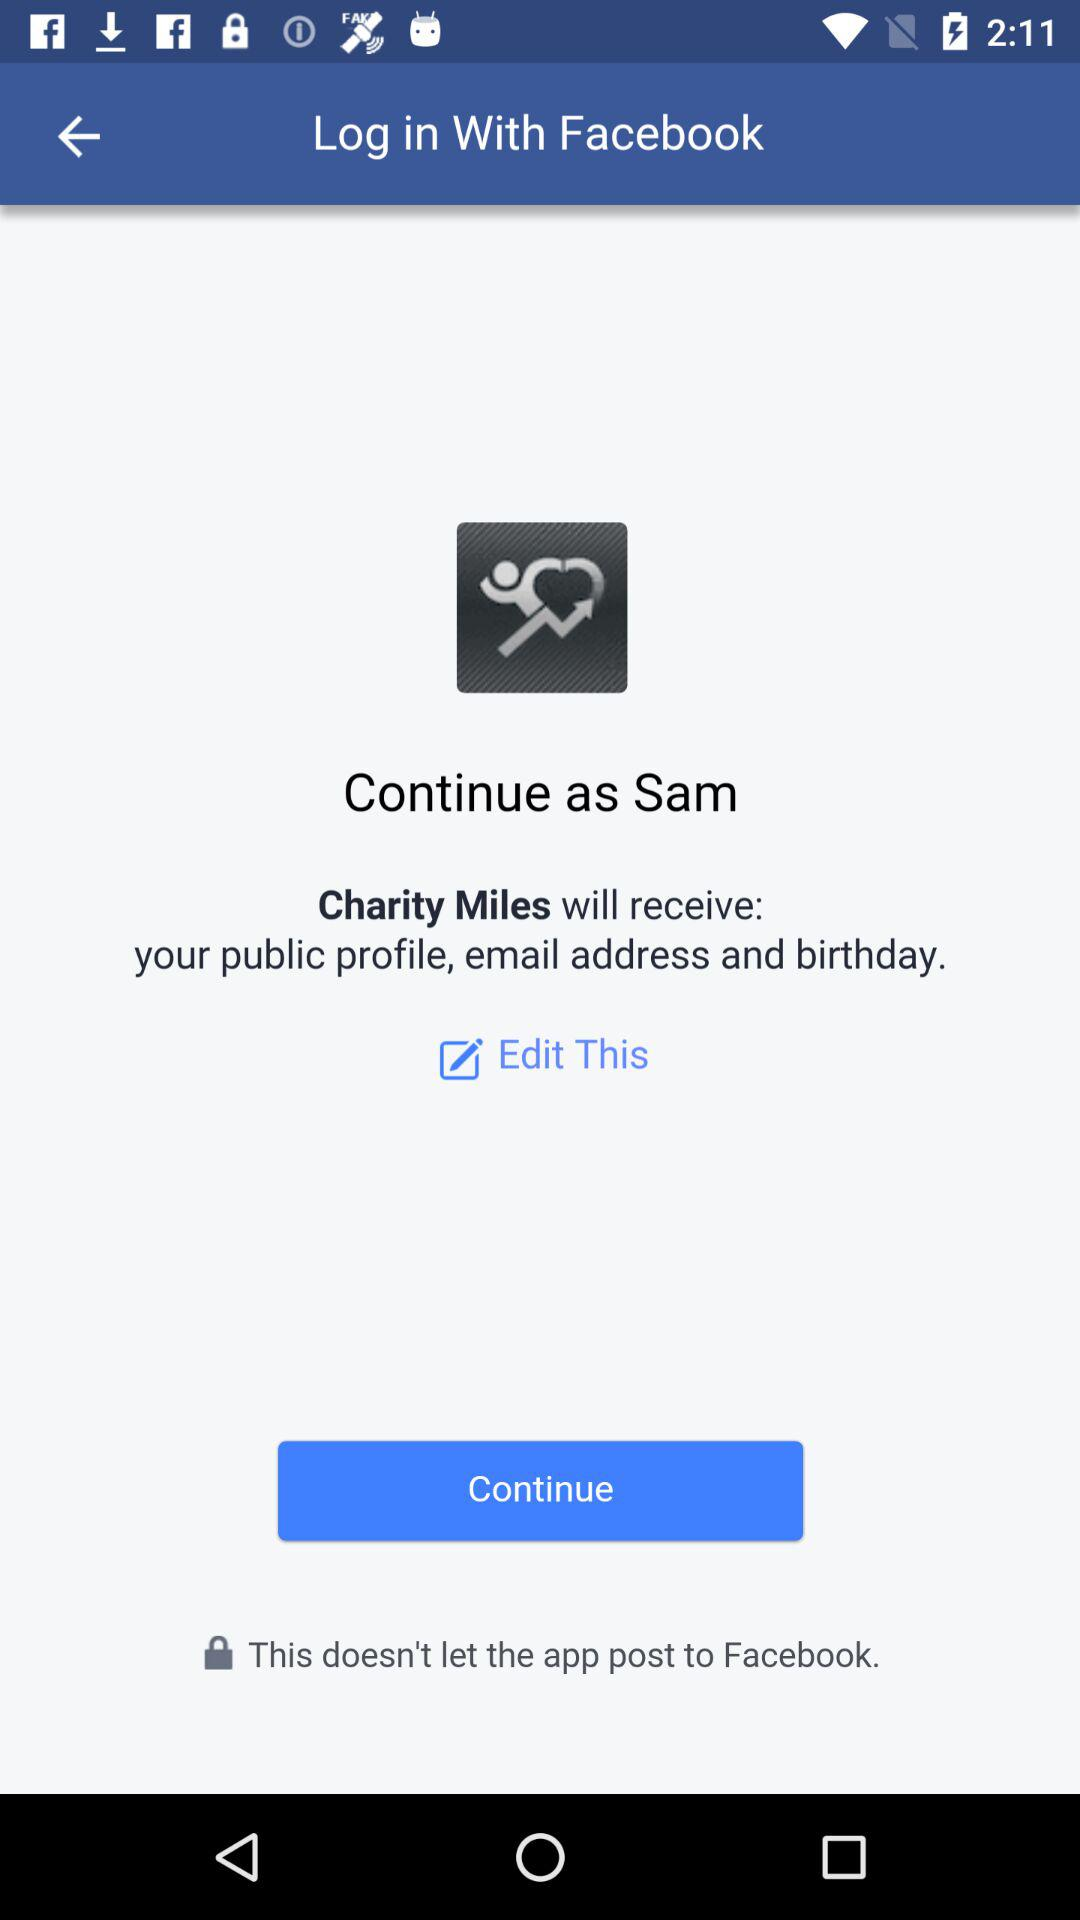Which information will "Charity Miles" receive? "Charity Miles" will receive the public profile, email address and birthday. 